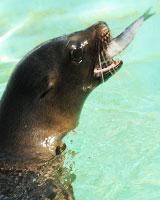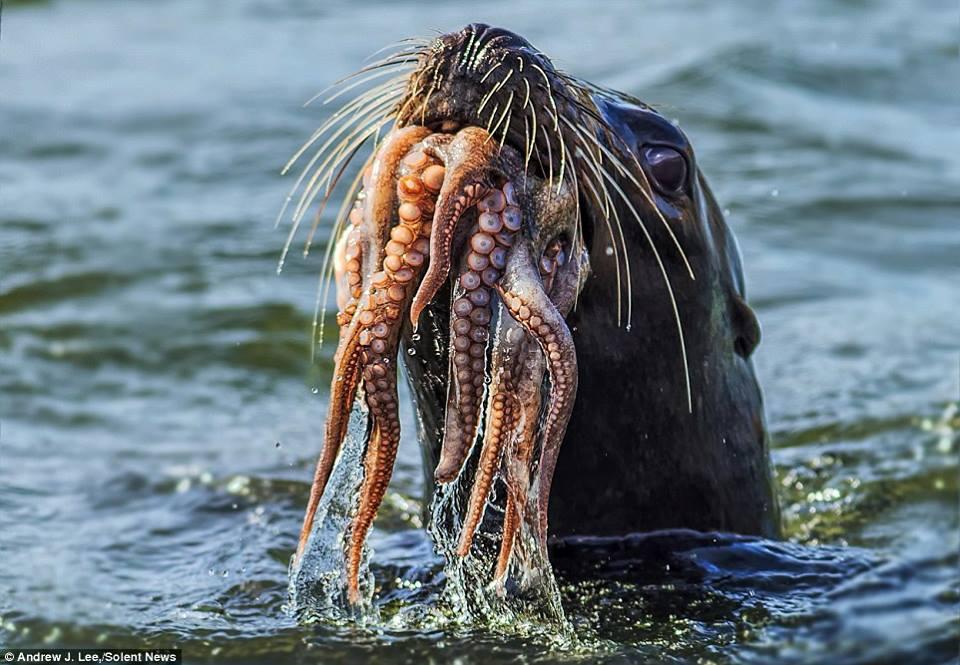The first image is the image on the left, the second image is the image on the right. Examine the images to the left and right. Is the description "At least one image shows a sea lion with octopus tentacles in its mouth." accurate? Answer yes or no. Yes. The first image is the image on the left, the second image is the image on the right. Assess this claim about the two images: "Atleast one image of a seal eating an octopus". Correct or not? Answer yes or no. Yes. 